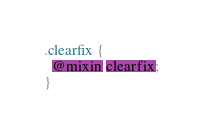<code> <loc_0><loc_0><loc_500><loc_500><_CSS_>.clearfix {
  @mixin clearfix;
}
</code> 